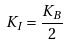Convert formula to latex. <formula><loc_0><loc_0><loc_500><loc_500>K _ { I } = \frac { K _ { B } } { 2 }</formula> 